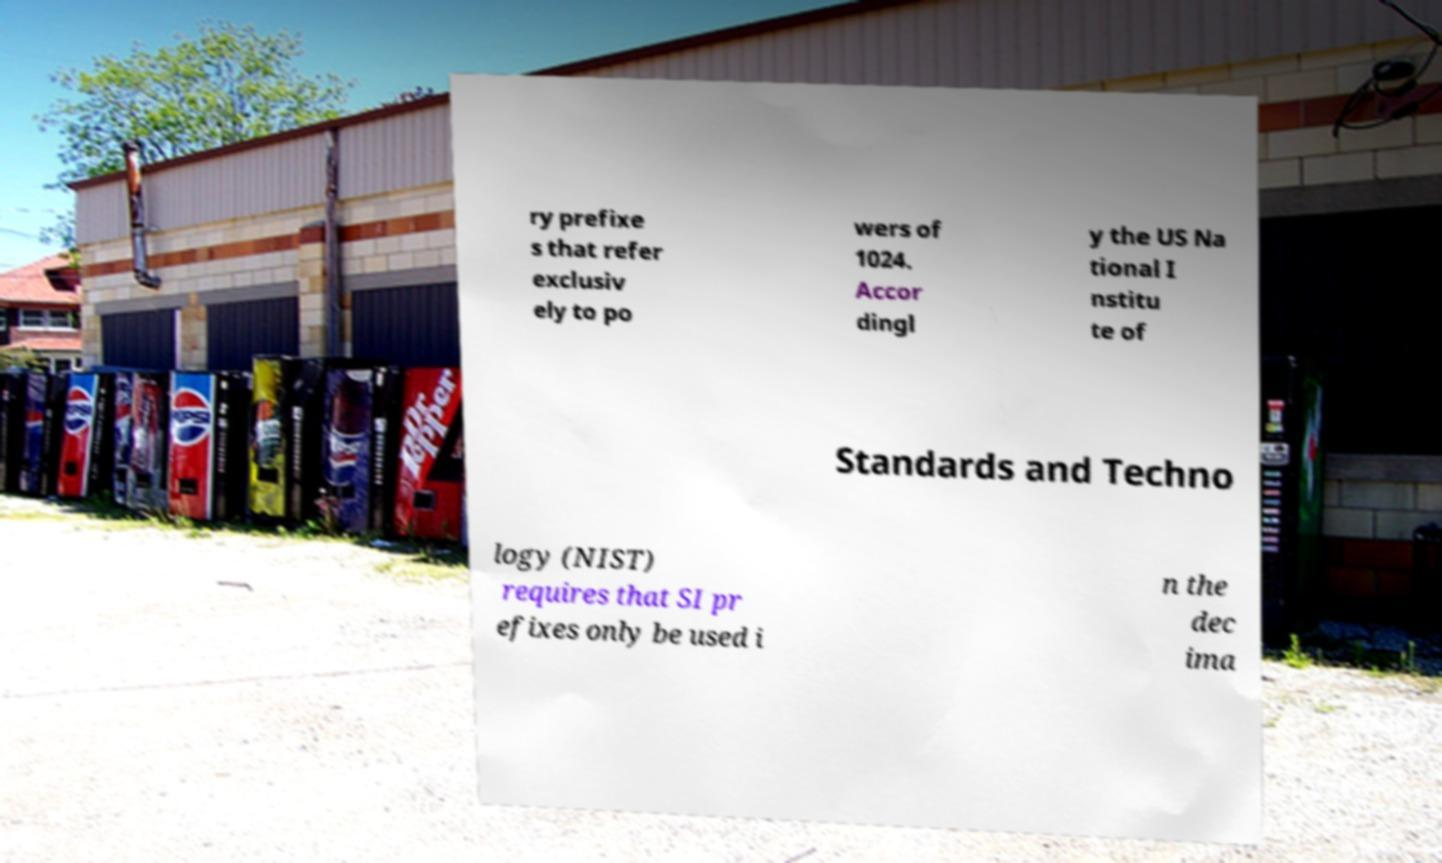Could you assist in decoding the text presented in this image and type it out clearly? ry prefixe s that refer exclusiv ely to po wers of 1024. Accor dingl y the US Na tional I nstitu te of Standards and Techno logy (NIST) requires that SI pr efixes only be used i n the dec ima 